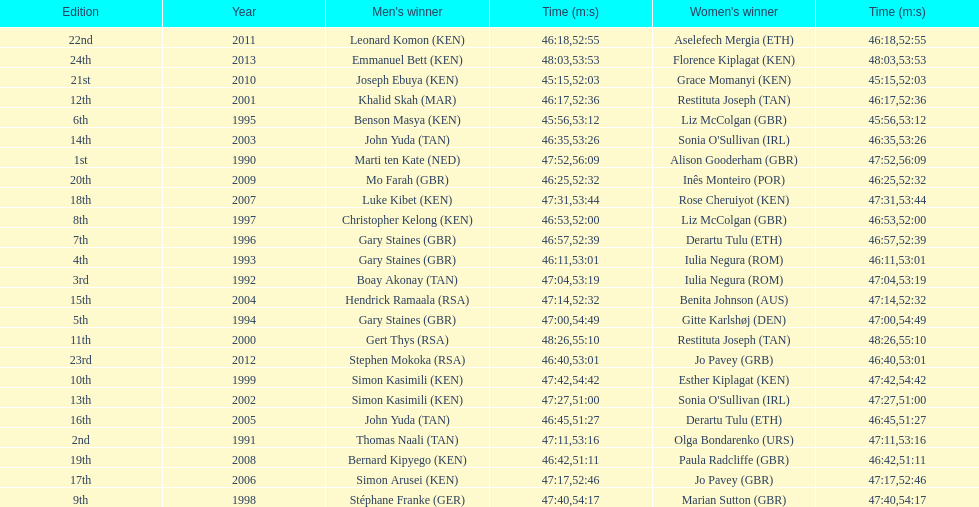How many men winners had times at least 46 minutes or under? 2. 